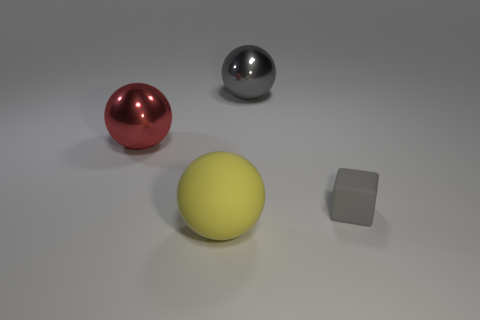What material is the gray object in front of the big gray metallic thing right of the matte thing on the left side of the gray block?
Provide a succinct answer. Rubber. Do the red sphere and the gray object behind the big red metallic object have the same material?
Give a very brief answer. Yes. What is the material of the red object that is the same shape as the big gray thing?
Your response must be concise. Metal. Are there any other things that are made of the same material as the large gray ball?
Keep it short and to the point. Yes. Are there more tiny gray matte blocks in front of the tiny gray cube than large yellow rubber things behind the yellow ball?
Ensure brevity in your answer.  No. What is the shape of the other object that is made of the same material as the small gray object?
Your answer should be very brief. Sphere. How many other objects are there of the same shape as the small rubber thing?
Offer a terse response. 0. There is a shiny thing in front of the large gray shiny object; what is its shape?
Make the answer very short. Sphere. What color is the rubber ball?
Your response must be concise. Yellow. What number of other objects are the same size as the red thing?
Your response must be concise. 2. 